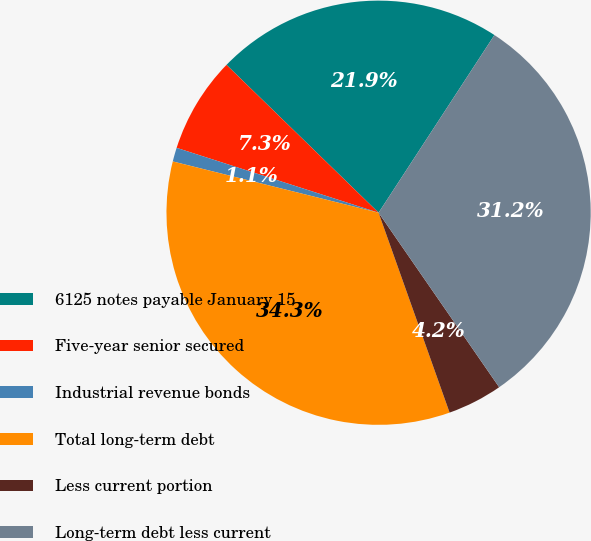Convert chart to OTSL. <chart><loc_0><loc_0><loc_500><loc_500><pie_chart><fcel>6125 notes payable January 15<fcel>Five-year senior secured<fcel>Industrial revenue bonds<fcel>Total long-term debt<fcel>Less current portion<fcel>Long-term debt less current<nl><fcel>21.92%<fcel>7.33%<fcel>1.06%<fcel>34.32%<fcel>4.19%<fcel>31.18%<nl></chart> 